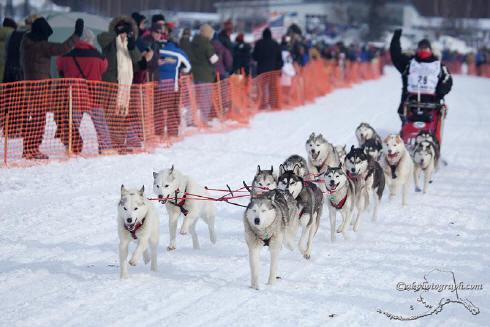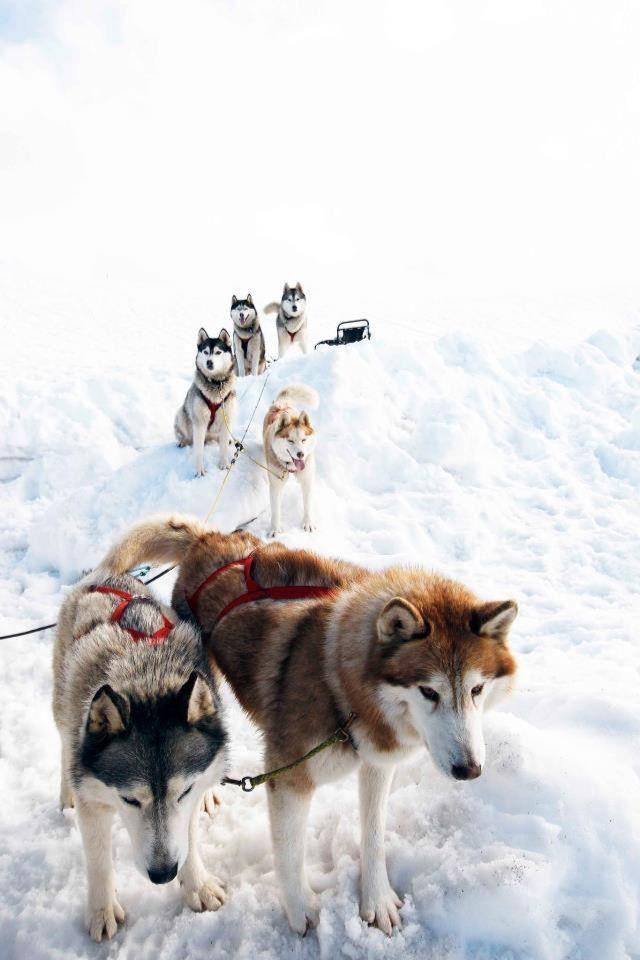The first image is the image on the left, the second image is the image on the right. For the images displayed, is the sentence "The Huskies are running in both images." factually correct? Answer yes or no. No. The first image is the image on the left, the second image is the image on the right. Analyze the images presented: Is the assertion "Some dogs are wearing booties." valid? Answer yes or no. No. 